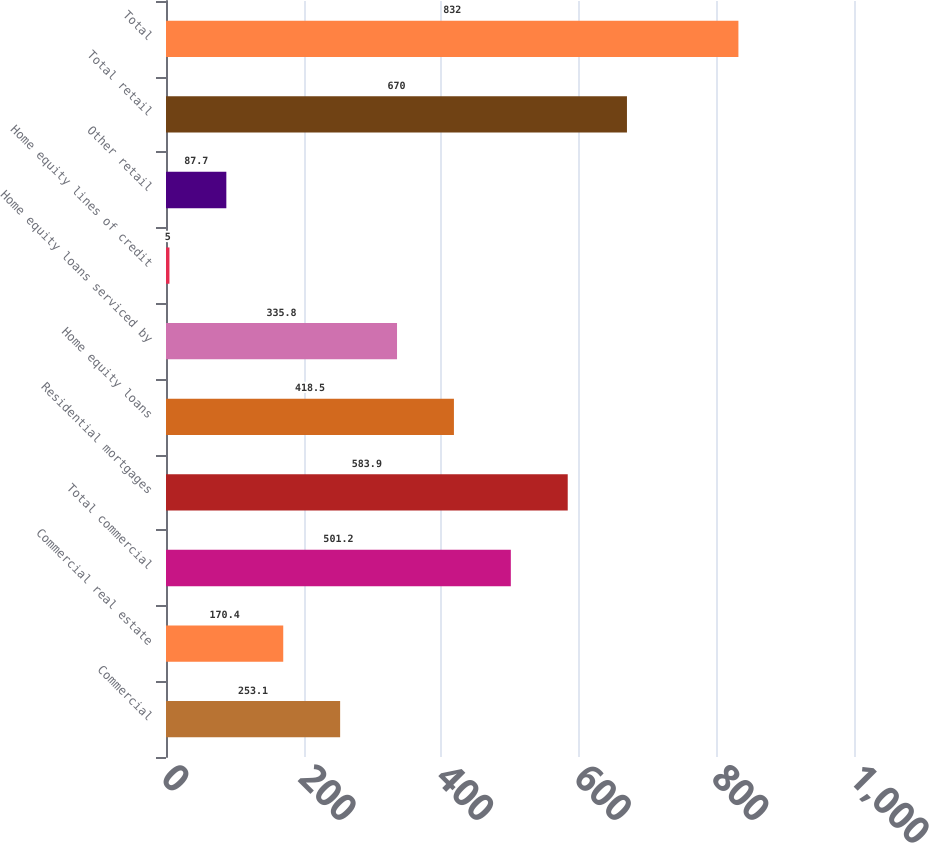Convert chart. <chart><loc_0><loc_0><loc_500><loc_500><bar_chart><fcel>Commercial<fcel>Commercial real estate<fcel>Total commercial<fcel>Residential mortgages<fcel>Home equity loans<fcel>Home equity loans serviced by<fcel>Home equity lines of credit<fcel>Other retail<fcel>Total retail<fcel>Total<nl><fcel>253.1<fcel>170.4<fcel>501.2<fcel>583.9<fcel>418.5<fcel>335.8<fcel>5<fcel>87.7<fcel>670<fcel>832<nl></chart> 